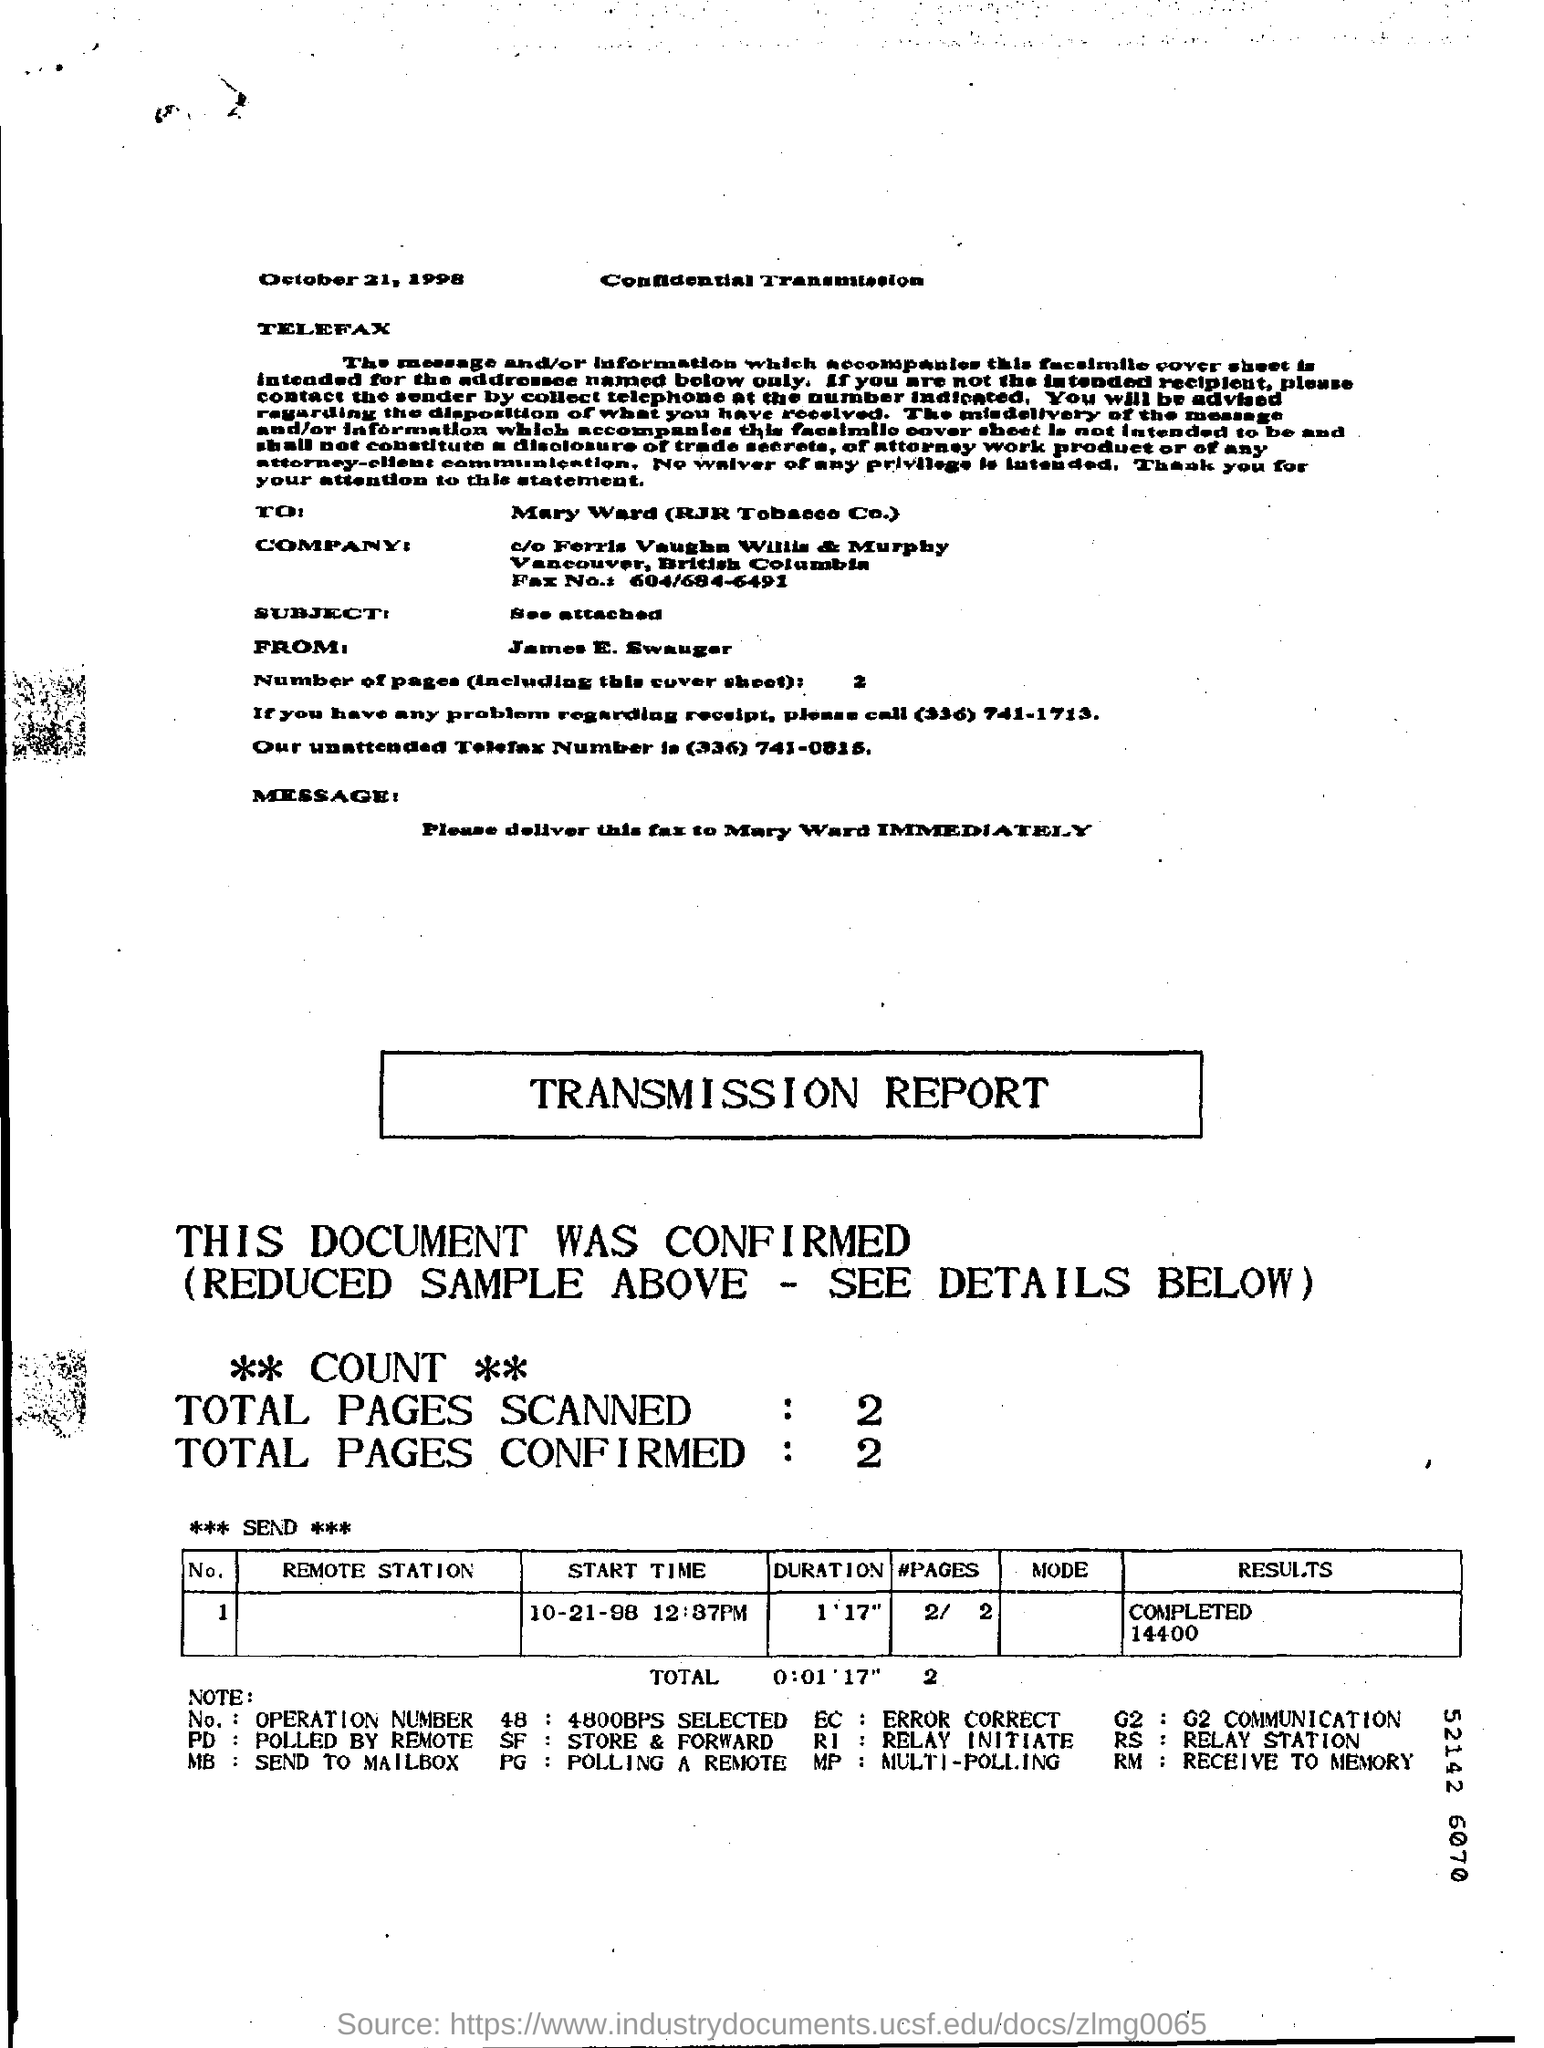Give some essential details in this illustration. The document contains the date of October 21, 1998. 